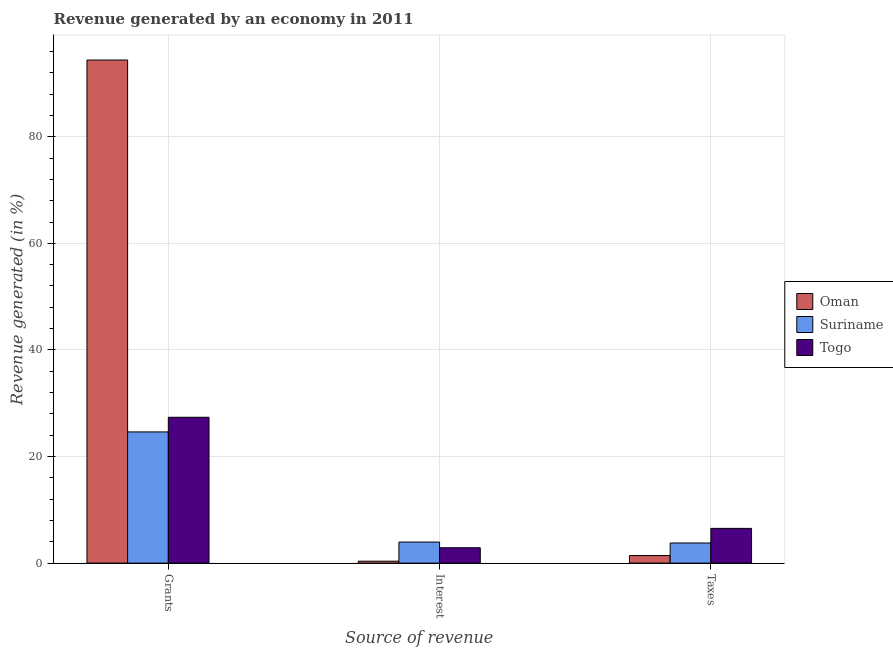Are the number of bars per tick equal to the number of legend labels?
Make the answer very short. Yes. What is the label of the 3rd group of bars from the left?
Ensure brevity in your answer.  Taxes. What is the percentage of revenue generated by grants in Togo?
Make the answer very short. 27.36. Across all countries, what is the maximum percentage of revenue generated by grants?
Your answer should be compact. 94.39. Across all countries, what is the minimum percentage of revenue generated by interest?
Your answer should be very brief. 0.36. In which country was the percentage of revenue generated by taxes maximum?
Your answer should be very brief. Togo. In which country was the percentage of revenue generated by taxes minimum?
Offer a very short reply. Oman. What is the total percentage of revenue generated by interest in the graph?
Provide a short and direct response. 7.2. What is the difference between the percentage of revenue generated by taxes in Suriname and that in Togo?
Make the answer very short. -2.74. What is the difference between the percentage of revenue generated by grants in Oman and the percentage of revenue generated by taxes in Togo?
Your response must be concise. 87.87. What is the average percentage of revenue generated by grants per country?
Your response must be concise. 48.79. What is the difference between the percentage of revenue generated by interest and percentage of revenue generated by grants in Suriname?
Your answer should be very brief. -20.66. What is the ratio of the percentage of revenue generated by taxes in Suriname to that in Oman?
Ensure brevity in your answer.  2.66. What is the difference between the highest and the second highest percentage of revenue generated by taxes?
Your response must be concise. 2.74. What is the difference between the highest and the lowest percentage of revenue generated by interest?
Give a very brief answer. 3.59. Is the sum of the percentage of revenue generated by taxes in Togo and Suriname greater than the maximum percentage of revenue generated by grants across all countries?
Provide a short and direct response. No. What does the 3rd bar from the left in Taxes represents?
Make the answer very short. Togo. What does the 2nd bar from the right in Grants represents?
Offer a very short reply. Suriname. Is it the case that in every country, the sum of the percentage of revenue generated by grants and percentage of revenue generated by interest is greater than the percentage of revenue generated by taxes?
Your answer should be very brief. Yes. Does the graph contain grids?
Your response must be concise. Yes. What is the title of the graph?
Offer a terse response. Revenue generated by an economy in 2011. What is the label or title of the X-axis?
Your response must be concise. Source of revenue. What is the label or title of the Y-axis?
Offer a terse response. Revenue generated (in %). What is the Revenue generated (in %) of Oman in Grants?
Offer a very short reply. 94.39. What is the Revenue generated (in %) in Suriname in Grants?
Give a very brief answer. 24.62. What is the Revenue generated (in %) in Togo in Grants?
Keep it short and to the point. 27.36. What is the Revenue generated (in %) of Oman in Interest?
Keep it short and to the point. 0.36. What is the Revenue generated (in %) of Suriname in Interest?
Ensure brevity in your answer.  3.95. What is the Revenue generated (in %) in Togo in Interest?
Offer a very short reply. 2.88. What is the Revenue generated (in %) in Oman in Taxes?
Your answer should be very brief. 1.42. What is the Revenue generated (in %) of Suriname in Taxes?
Keep it short and to the point. 3.78. What is the Revenue generated (in %) of Togo in Taxes?
Your answer should be very brief. 6.52. Across all Source of revenue, what is the maximum Revenue generated (in %) in Oman?
Provide a short and direct response. 94.39. Across all Source of revenue, what is the maximum Revenue generated (in %) of Suriname?
Offer a very short reply. 24.62. Across all Source of revenue, what is the maximum Revenue generated (in %) of Togo?
Make the answer very short. 27.36. Across all Source of revenue, what is the minimum Revenue generated (in %) of Oman?
Keep it short and to the point. 0.36. Across all Source of revenue, what is the minimum Revenue generated (in %) in Suriname?
Your answer should be very brief. 3.78. Across all Source of revenue, what is the minimum Revenue generated (in %) of Togo?
Your response must be concise. 2.88. What is the total Revenue generated (in %) of Oman in the graph?
Provide a succinct answer. 96.17. What is the total Revenue generated (in %) in Suriname in the graph?
Offer a very short reply. 32.34. What is the total Revenue generated (in %) in Togo in the graph?
Give a very brief answer. 36.76. What is the difference between the Revenue generated (in %) in Oman in Grants and that in Interest?
Your answer should be very brief. 94.03. What is the difference between the Revenue generated (in %) in Suriname in Grants and that in Interest?
Provide a short and direct response. 20.66. What is the difference between the Revenue generated (in %) in Togo in Grants and that in Interest?
Your answer should be compact. 24.48. What is the difference between the Revenue generated (in %) of Oman in Grants and that in Taxes?
Give a very brief answer. 92.97. What is the difference between the Revenue generated (in %) of Suriname in Grants and that in Taxes?
Ensure brevity in your answer.  20.84. What is the difference between the Revenue generated (in %) in Togo in Grants and that in Taxes?
Your response must be concise. 20.85. What is the difference between the Revenue generated (in %) in Oman in Interest and that in Taxes?
Keep it short and to the point. -1.06. What is the difference between the Revenue generated (in %) in Suriname in Interest and that in Taxes?
Give a very brief answer. 0.18. What is the difference between the Revenue generated (in %) of Togo in Interest and that in Taxes?
Provide a short and direct response. -3.63. What is the difference between the Revenue generated (in %) of Oman in Grants and the Revenue generated (in %) of Suriname in Interest?
Provide a short and direct response. 90.44. What is the difference between the Revenue generated (in %) of Oman in Grants and the Revenue generated (in %) of Togo in Interest?
Your answer should be very brief. 91.51. What is the difference between the Revenue generated (in %) in Suriname in Grants and the Revenue generated (in %) in Togo in Interest?
Make the answer very short. 21.73. What is the difference between the Revenue generated (in %) of Oman in Grants and the Revenue generated (in %) of Suriname in Taxes?
Your response must be concise. 90.61. What is the difference between the Revenue generated (in %) of Oman in Grants and the Revenue generated (in %) of Togo in Taxes?
Offer a terse response. 87.87. What is the difference between the Revenue generated (in %) of Suriname in Grants and the Revenue generated (in %) of Togo in Taxes?
Offer a terse response. 18.1. What is the difference between the Revenue generated (in %) in Oman in Interest and the Revenue generated (in %) in Suriname in Taxes?
Offer a terse response. -3.42. What is the difference between the Revenue generated (in %) in Oman in Interest and the Revenue generated (in %) in Togo in Taxes?
Provide a succinct answer. -6.16. What is the difference between the Revenue generated (in %) in Suriname in Interest and the Revenue generated (in %) in Togo in Taxes?
Make the answer very short. -2.56. What is the average Revenue generated (in %) of Oman per Source of revenue?
Your answer should be very brief. 32.06. What is the average Revenue generated (in %) in Suriname per Source of revenue?
Ensure brevity in your answer.  10.78. What is the average Revenue generated (in %) of Togo per Source of revenue?
Provide a succinct answer. 12.25. What is the difference between the Revenue generated (in %) of Oman and Revenue generated (in %) of Suriname in Grants?
Your answer should be very brief. 69.77. What is the difference between the Revenue generated (in %) in Oman and Revenue generated (in %) in Togo in Grants?
Keep it short and to the point. 67.03. What is the difference between the Revenue generated (in %) of Suriname and Revenue generated (in %) of Togo in Grants?
Provide a succinct answer. -2.75. What is the difference between the Revenue generated (in %) in Oman and Revenue generated (in %) in Suriname in Interest?
Give a very brief answer. -3.59. What is the difference between the Revenue generated (in %) of Oman and Revenue generated (in %) of Togo in Interest?
Provide a succinct answer. -2.52. What is the difference between the Revenue generated (in %) of Suriname and Revenue generated (in %) of Togo in Interest?
Your response must be concise. 1.07. What is the difference between the Revenue generated (in %) of Oman and Revenue generated (in %) of Suriname in Taxes?
Provide a short and direct response. -2.35. What is the difference between the Revenue generated (in %) of Oman and Revenue generated (in %) of Togo in Taxes?
Your answer should be compact. -5.1. What is the difference between the Revenue generated (in %) in Suriname and Revenue generated (in %) in Togo in Taxes?
Keep it short and to the point. -2.74. What is the ratio of the Revenue generated (in %) in Oman in Grants to that in Interest?
Your answer should be compact. 262.17. What is the ratio of the Revenue generated (in %) in Suriname in Grants to that in Interest?
Provide a succinct answer. 6.23. What is the ratio of the Revenue generated (in %) in Togo in Grants to that in Interest?
Provide a short and direct response. 9.49. What is the ratio of the Revenue generated (in %) of Oman in Grants to that in Taxes?
Give a very brief answer. 66.37. What is the ratio of the Revenue generated (in %) in Suriname in Grants to that in Taxes?
Ensure brevity in your answer.  6.52. What is the ratio of the Revenue generated (in %) in Togo in Grants to that in Taxes?
Your answer should be very brief. 4.2. What is the ratio of the Revenue generated (in %) in Oman in Interest to that in Taxes?
Give a very brief answer. 0.25. What is the ratio of the Revenue generated (in %) of Suriname in Interest to that in Taxes?
Offer a terse response. 1.05. What is the ratio of the Revenue generated (in %) in Togo in Interest to that in Taxes?
Give a very brief answer. 0.44. What is the difference between the highest and the second highest Revenue generated (in %) of Oman?
Offer a terse response. 92.97. What is the difference between the highest and the second highest Revenue generated (in %) of Suriname?
Your response must be concise. 20.66. What is the difference between the highest and the second highest Revenue generated (in %) of Togo?
Ensure brevity in your answer.  20.85. What is the difference between the highest and the lowest Revenue generated (in %) of Oman?
Offer a terse response. 94.03. What is the difference between the highest and the lowest Revenue generated (in %) in Suriname?
Give a very brief answer. 20.84. What is the difference between the highest and the lowest Revenue generated (in %) of Togo?
Give a very brief answer. 24.48. 